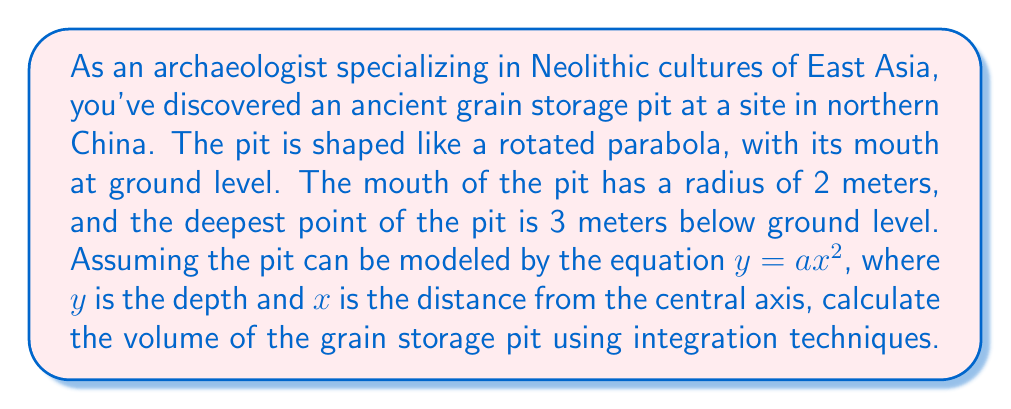Teach me how to tackle this problem. Let's approach this step-by-step:

1) First, we need to find the equation of the parabola. We know two points:
   $(0, 3)$ at the bottom of the pit, and $(2, 0)$ at the mouth.

2) Using the general form $y = ax^2$, we can find $a$:
   $0 = a(2)^2$
   $0 = 4a$
   $a = -\frac{3}{4}$

3) So, the equation of the parabola is $y = -\frac{3}{4}x^2 + 3$

4) To find the volume, we need to use the washer method of integration. The volume is given by:

   $$V = \pi \int_0^2 [f(x)]^2 dx$$

   where $f(x)$ is the function that generates the solid when rotated around the y-axis.

5) In our case, we need to solve:

   $$V = \pi \int_0^2 x^2 dx$$

6) Integrating:

   $$V = \pi [\frac{1}{3}x^3]_0^2$$

7) Evaluating the integral:

   $$V = \pi (\frac{1}{3}(2^3) - 0)$$
   $$V = \pi (\frac{8}{3})$$
   $$V = \frac{8\pi}{3}$$

8) Therefore, the volume of the pit is $\frac{8\pi}{3}$ cubic meters.
Answer: The volume of the ancient grain storage pit is $\frac{8\pi}{3}$ cubic meters, or approximately 8.38 cubic meters. 